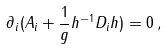Convert formula to latex. <formula><loc_0><loc_0><loc_500><loc_500>\partial _ { i } ( A _ { i } + \frac { 1 } { g } h ^ { - 1 } D _ { i } h ) = 0 \, ,</formula> 